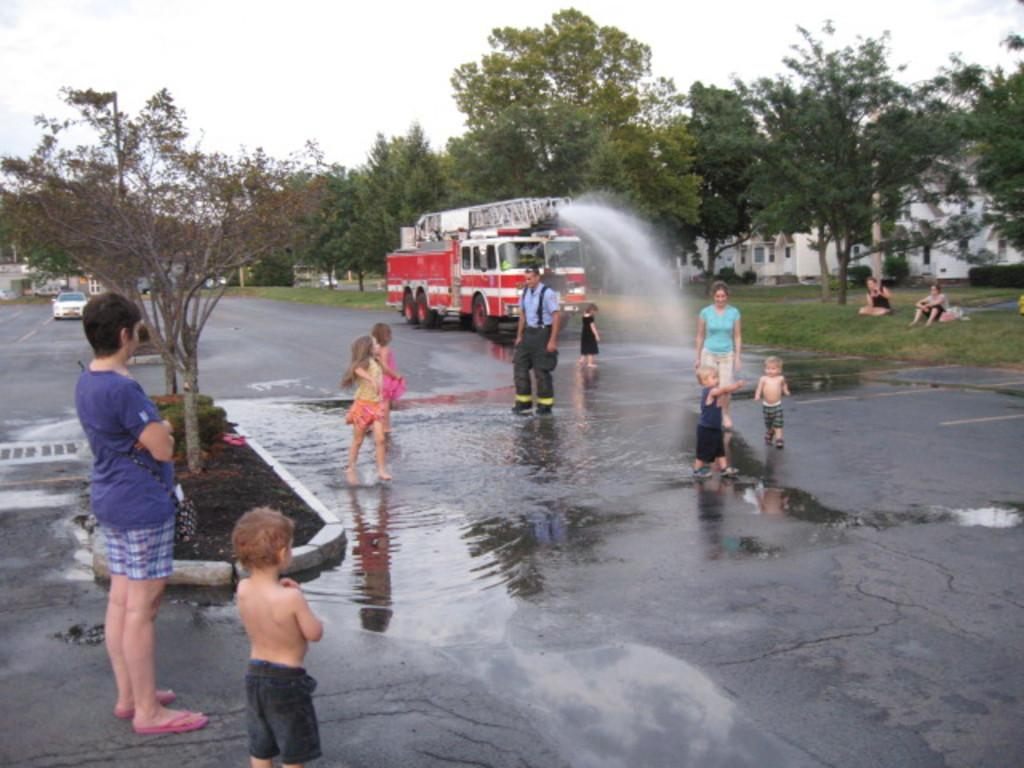What can be seen in the image besides people? There are vehicles, water on the road, two people sitting on the grass, trees, buildings, and the sky visible in the background. How many people are standing in the image? There are people standing in the image, but the exact number is not specified. What is the condition of the road in the image? The road in the image has water on it. What type of vegetation is present in the image? Trees are present in the image. What type of structures can be seen in the image? Buildings can be seen in the image. What type of rice is being served to the people sitting on the grass in the image? There is no rice present in the image; it features people standing, vehicles, water on the road, two people sitting on the grass, trees, buildings, and the sky visible in the background. 